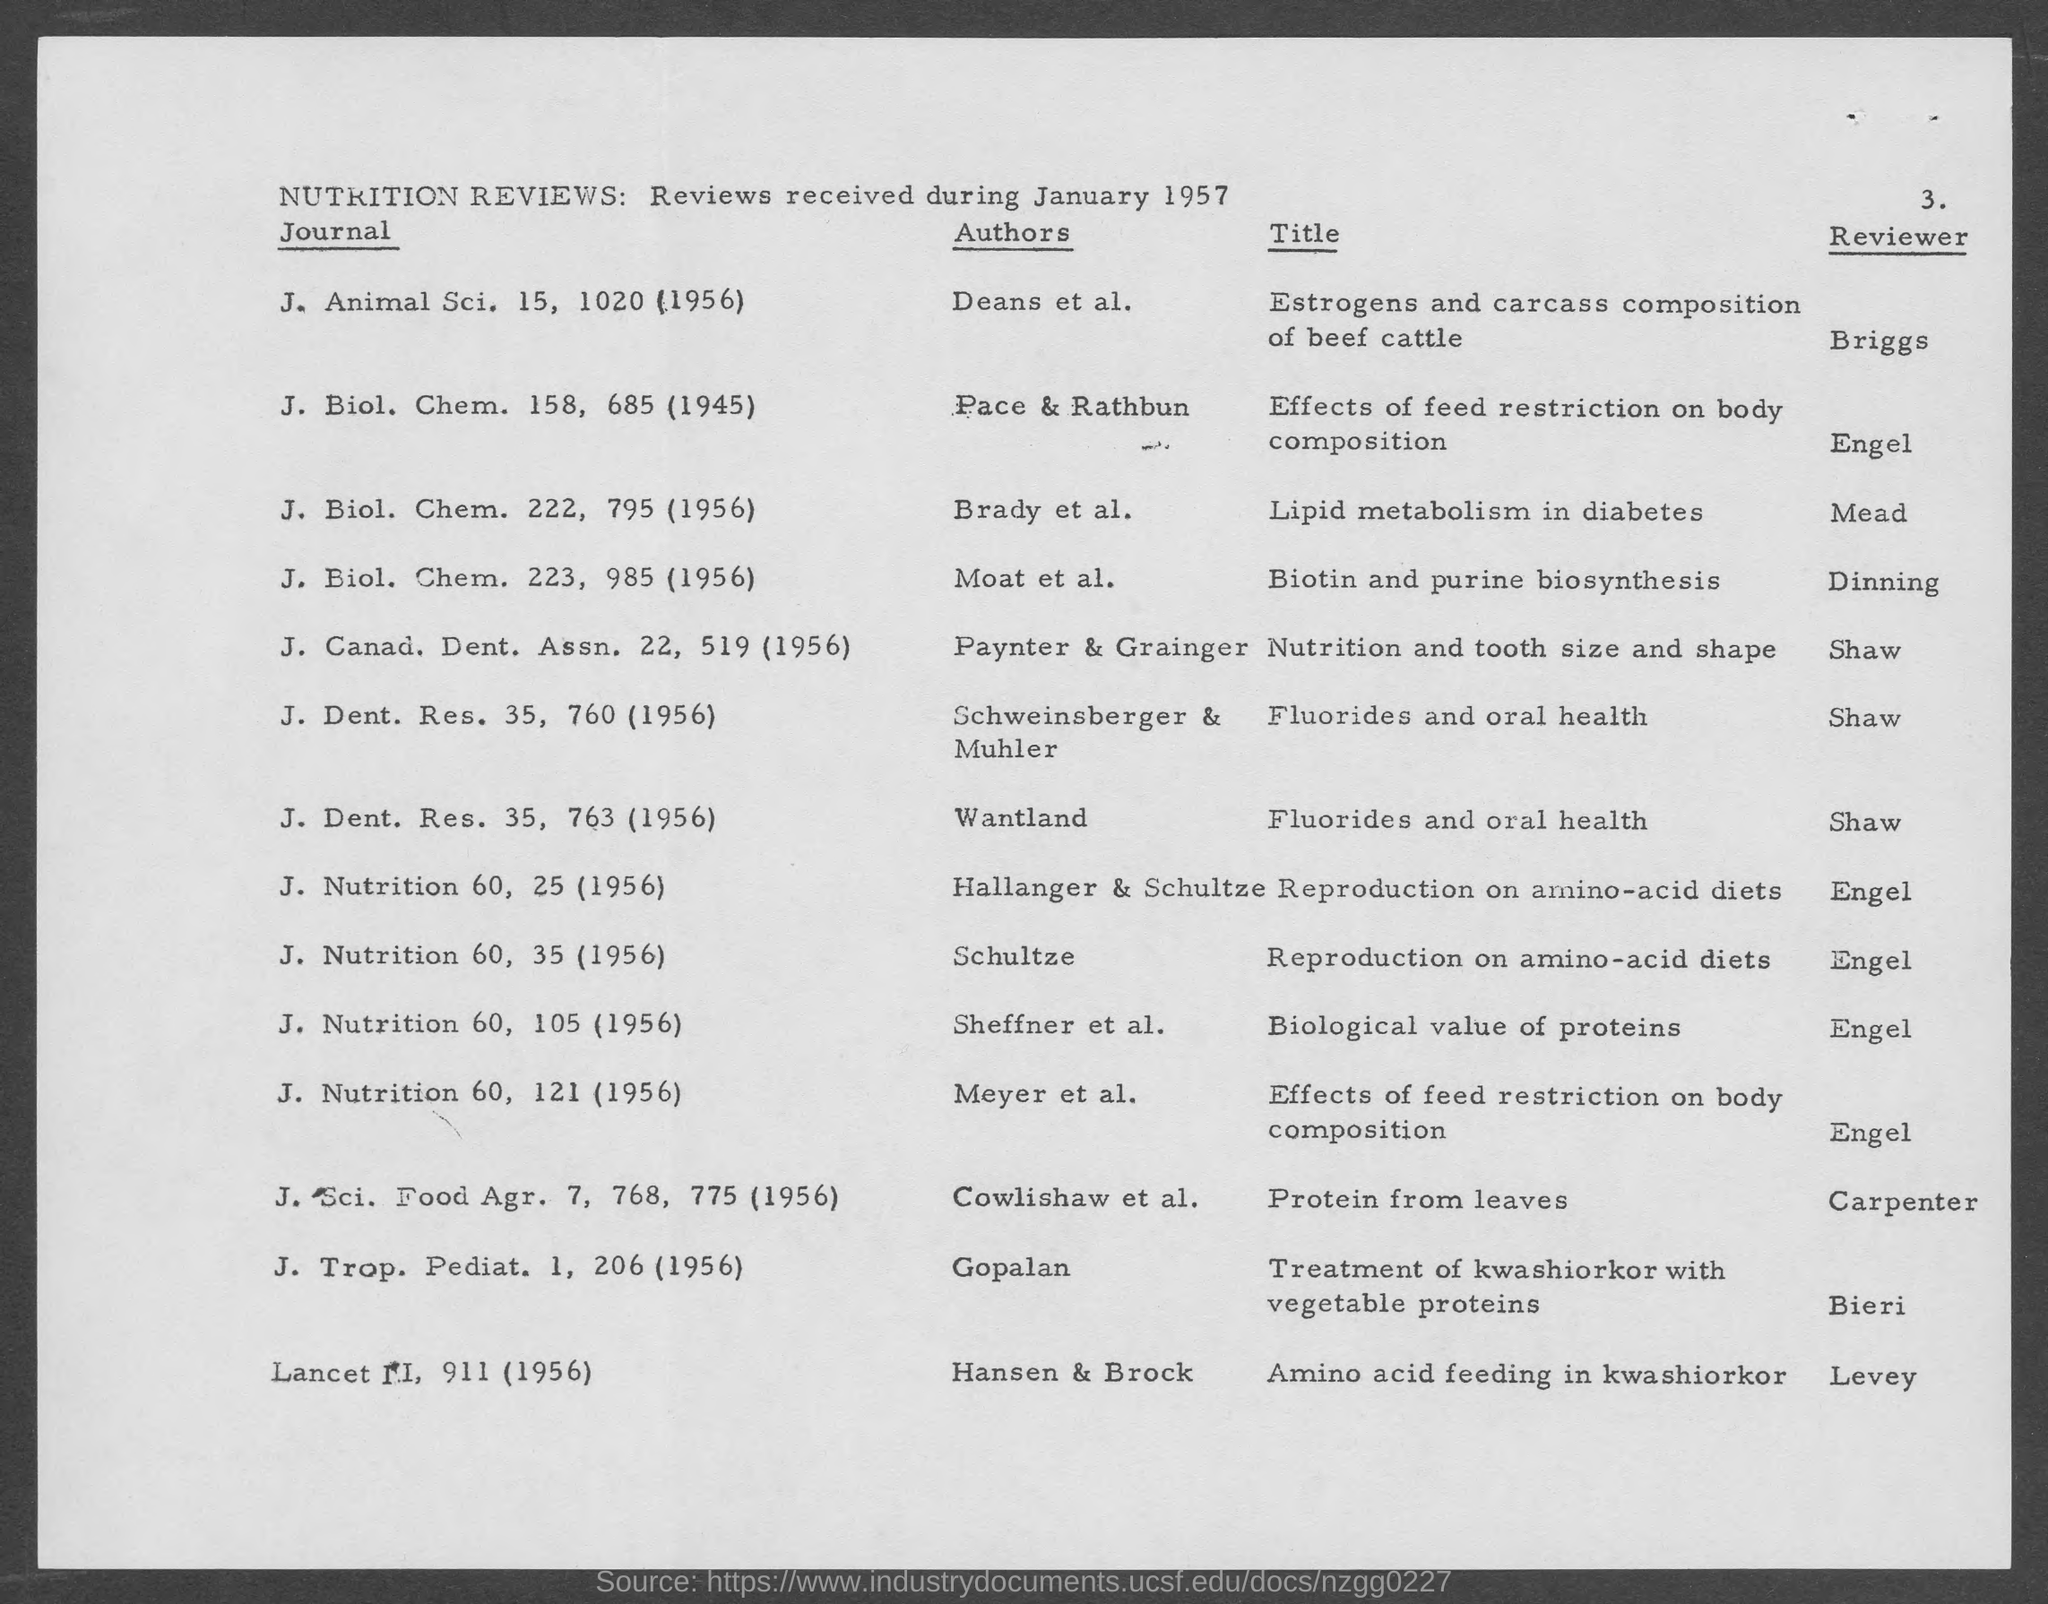Can you tell me which article discusses the biological value of proteins and who reviewed it? The article that discusses the biological value of proteins is listed under J. Nutrition 60, page 105 (1956), and it was reviewed by Engel.  Which publication addresses the issue of kwashiorkor and who authored the review? The issue of kwashiorkor is addressed in the publication 'J. Trop. Pediat. 1, 206 (1956)' by Gopalan and the review of 'Lancet ᴵᴵ, 911 (1956)' by Hansen & Brock, focusing on amino acid feeding in kwashiorkor, with the latter article reviewed by Levey. 